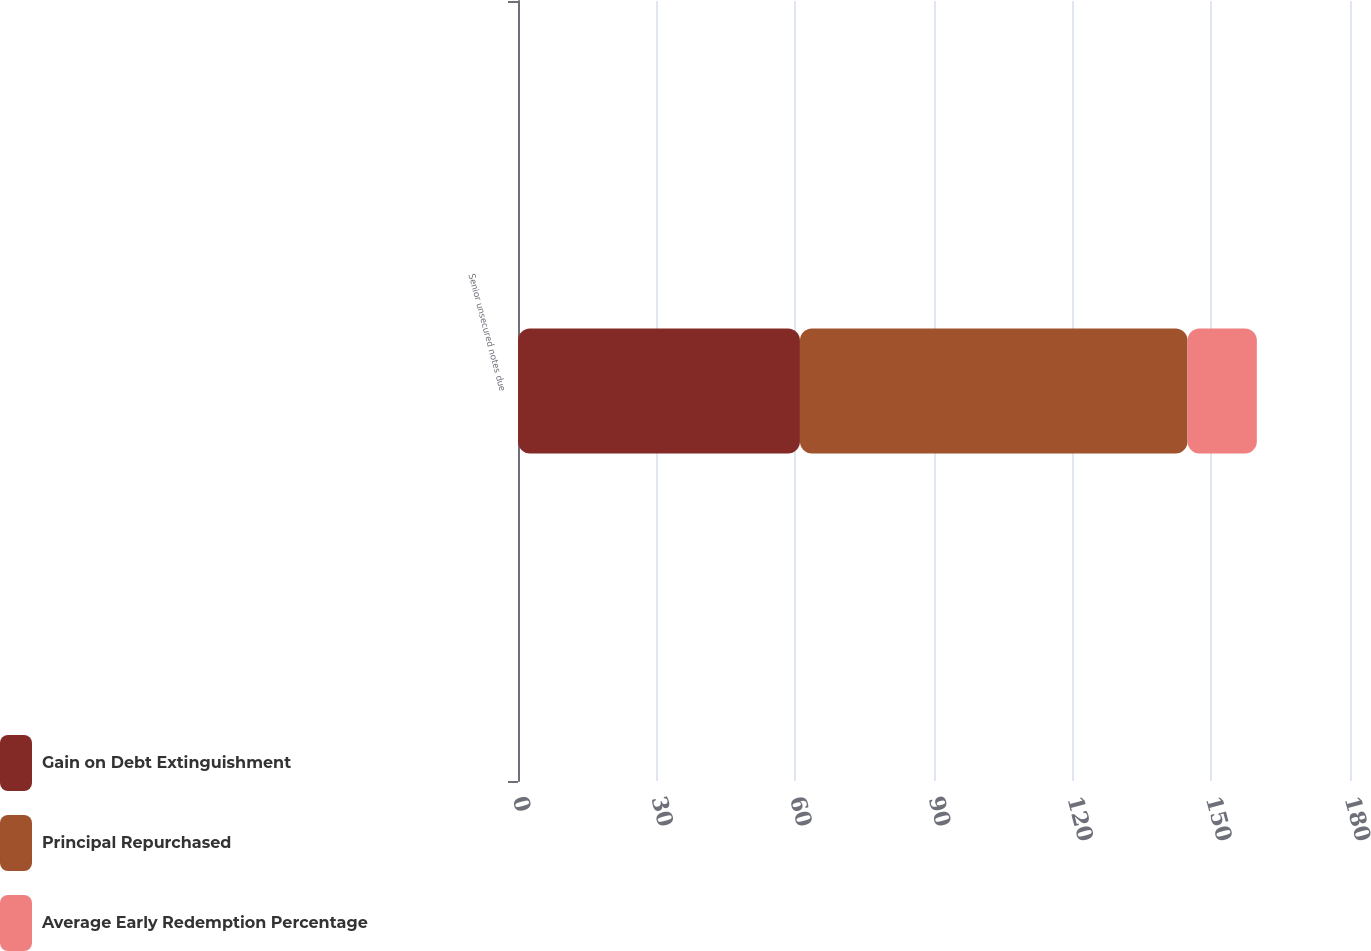Convert chart. <chart><loc_0><loc_0><loc_500><loc_500><stacked_bar_chart><ecel><fcel>Senior unsecured notes due<nl><fcel>Gain on Debt Extinguishment<fcel>61<nl><fcel>Principal Repurchased<fcel>83.85<nl><fcel>Average Early Redemption Percentage<fcel>15<nl></chart> 